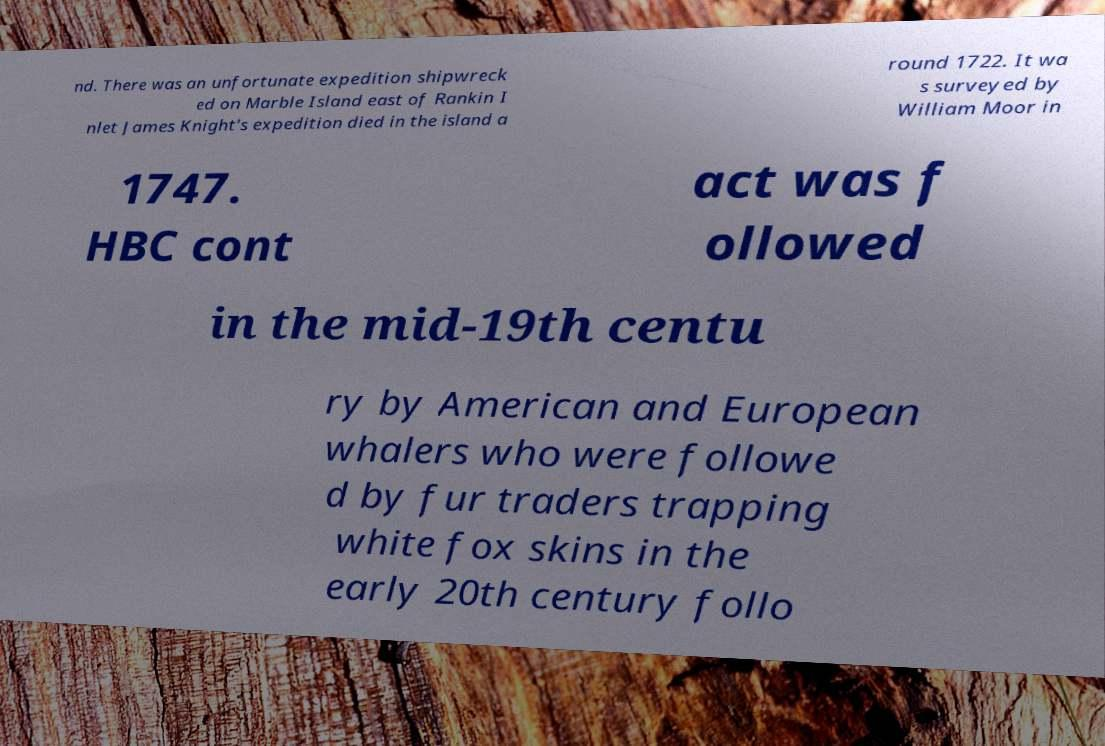I need the written content from this picture converted into text. Can you do that? nd. There was an unfortunate expedition shipwreck ed on Marble Island east of Rankin I nlet James Knight's expedition died in the island a round 1722. It wa s surveyed by William Moor in 1747. HBC cont act was f ollowed in the mid-19th centu ry by American and European whalers who were followe d by fur traders trapping white fox skins in the early 20th century follo 